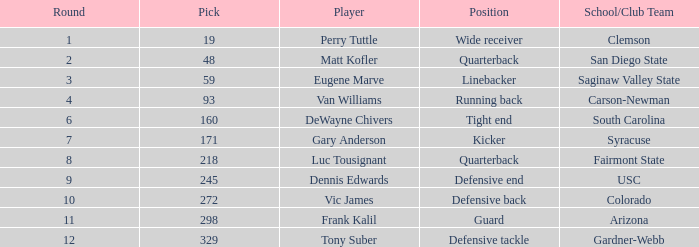Which player's pick is 160? DeWayne Chivers. 